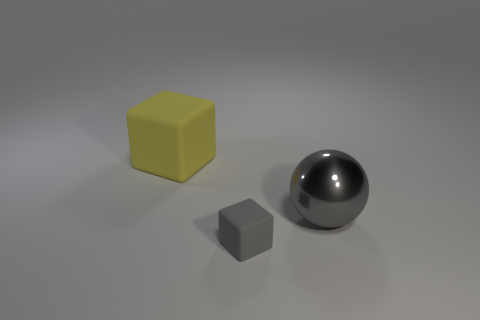Is there anything else that is the same size as the gray matte object?
Your response must be concise. No. What shape is the large object that is left of the large object that is in front of the large yellow matte object?
Provide a succinct answer. Cube. Do the gray thing that is to the left of the gray metal ball and the gray ball have the same material?
Provide a short and direct response. No. Are there the same number of tiny gray matte blocks that are left of the yellow thing and big gray objects that are right of the gray cube?
Provide a short and direct response. No. There is a large object that is the same color as the small rubber object; what is its material?
Your response must be concise. Metal. What number of yellow cubes are in front of the rubber thing in front of the gray metal thing?
Offer a terse response. 0. There is a block that is behind the big gray ball; is its color the same as the cube that is in front of the large gray metal ball?
Your answer should be very brief. No. What material is the yellow object that is the same size as the gray shiny ball?
Give a very brief answer. Rubber. What is the shape of the big gray metal object right of the rubber block left of the rubber block that is in front of the shiny thing?
Offer a very short reply. Sphere. What is the shape of the gray shiny object that is the same size as the yellow object?
Provide a short and direct response. Sphere. 